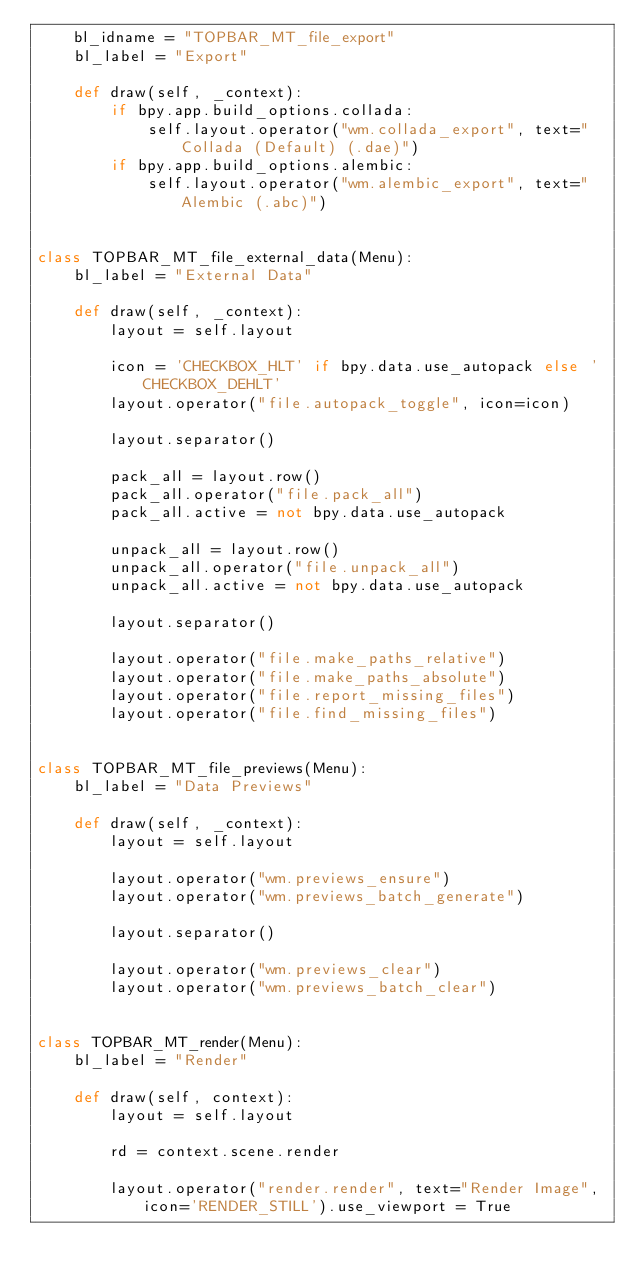<code> <loc_0><loc_0><loc_500><loc_500><_Python_>    bl_idname = "TOPBAR_MT_file_export"
    bl_label = "Export"

    def draw(self, _context):
        if bpy.app.build_options.collada:
            self.layout.operator("wm.collada_export", text="Collada (Default) (.dae)")
        if bpy.app.build_options.alembic:
            self.layout.operator("wm.alembic_export", text="Alembic (.abc)")


class TOPBAR_MT_file_external_data(Menu):
    bl_label = "External Data"

    def draw(self, _context):
        layout = self.layout

        icon = 'CHECKBOX_HLT' if bpy.data.use_autopack else 'CHECKBOX_DEHLT'
        layout.operator("file.autopack_toggle", icon=icon)

        layout.separator()

        pack_all = layout.row()
        pack_all.operator("file.pack_all")
        pack_all.active = not bpy.data.use_autopack

        unpack_all = layout.row()
        unpack_all.operator("file.unpack_all")
        unpack_all.active = not bpy.data.use_autopack

        layout.separator()

        layout.operator("file.make_paths_relative")
        layout.operator("file.make_paths_absolute")
        layout.operator("file.report_missing_files")
        layout.operator("file.find_missing_files")


class TOPBAR_MT_file_previews(Menu):
    bl_label = "Data Previews"

    def draw(self, _context):
        layout = self.layout

        layout.operator("wm.previews_ensure")
        layout.operator("wm.previews_batch_generate")

        layout.separator()

        layout.operator("wm.previews_clear")
        layout.operator("wm.previews_batch_clear")


class TOPBAR_MT_render(Menu):
    bl_label = "Render"

    def draw(self, context):
        layout = self.layout

        rd = context.scene.render

        layout.operator("render.render", text="Render Image", icon='RENDER_STILL').use_viewport = True</code> 